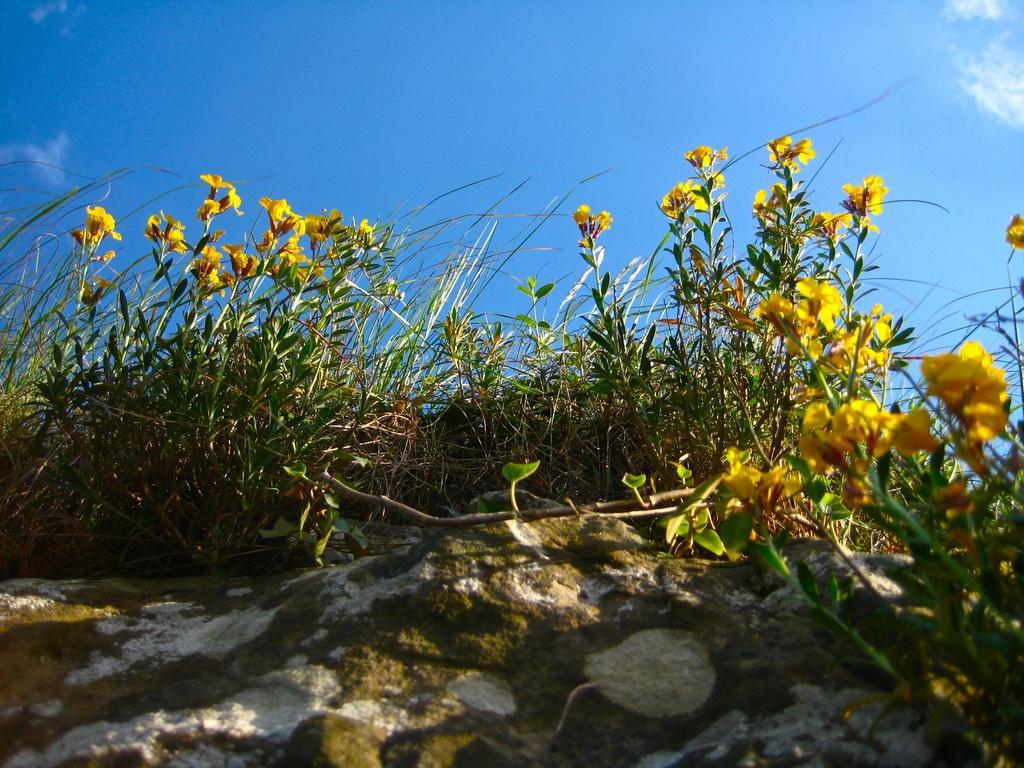What color is the sky in the image? The sky is blue at the top of the image. What type of vegetation can be seen in the center of the image? There is green grass with yellow flowers at the center of the image. What type of terrain is present at the bottom of the image? There is sand and mud at the bottom of the image. What time of day is depicted in the image? The time of day cannot be determined from the image, as there are no specific indicators of time. Is there a fire visible in the image? No, there is no fire present in the image. 